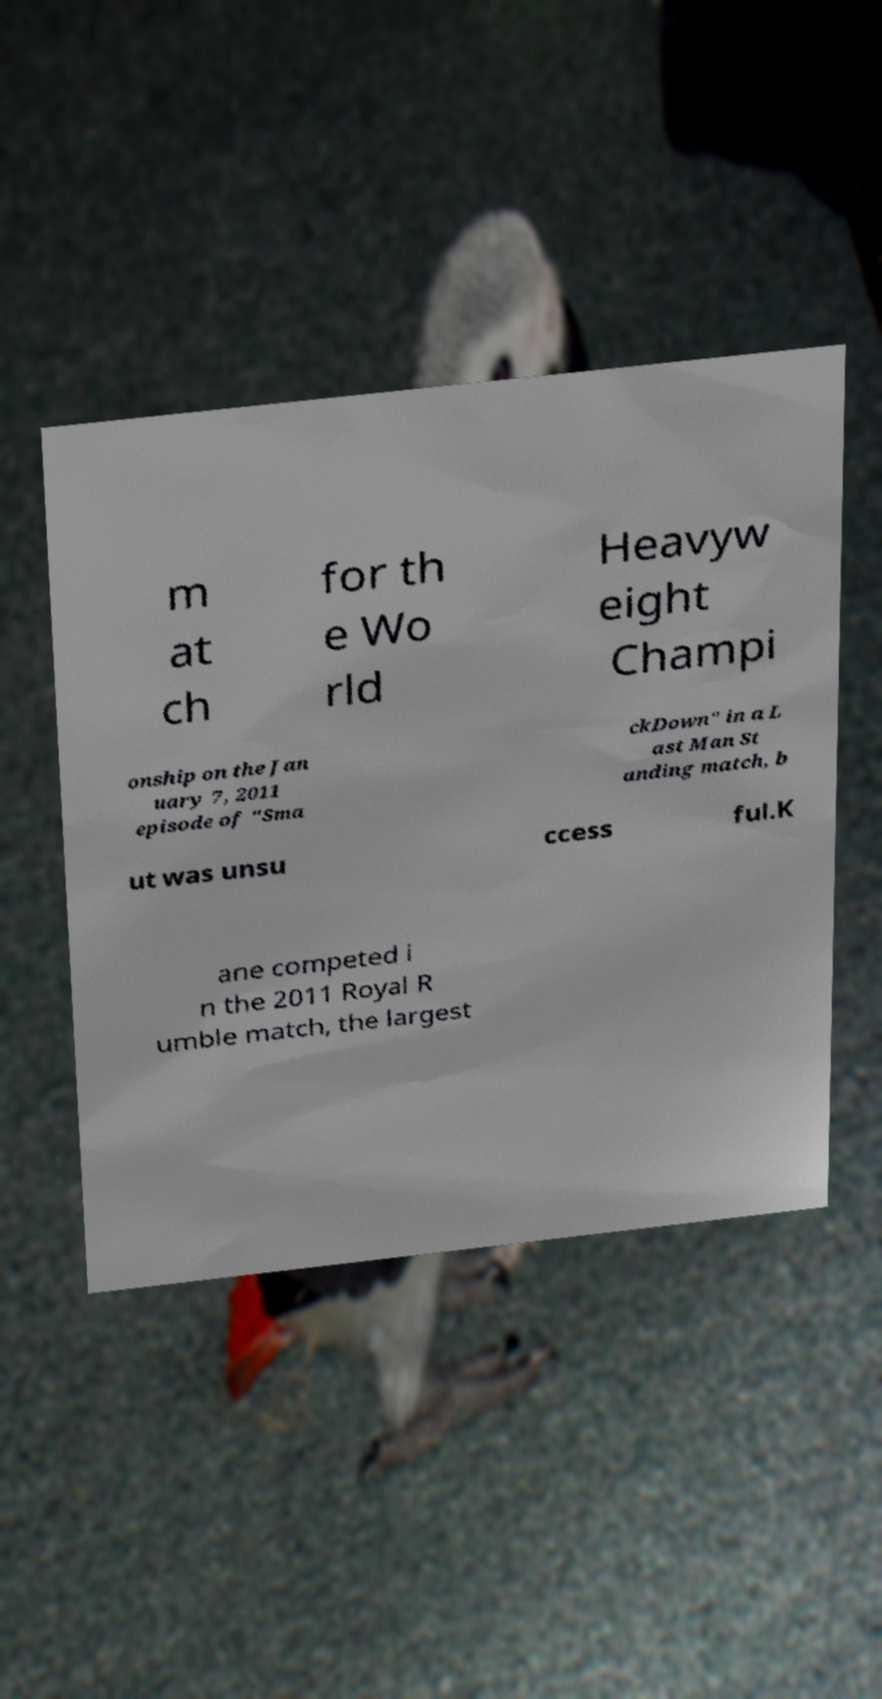Can you read and provide the text displayed in the image?This photo seems to have some interesting text. Can you extract and type it out for me? m at ch for th e Wo rld Heavyw eight Champi onship on the Jan uary 7, 2011 episode of "Sma ckDown" in a L ast Man St anding match, b ut was unsu ccess ful.K ane competed i n the 2011 Royal R umble match, the largest 